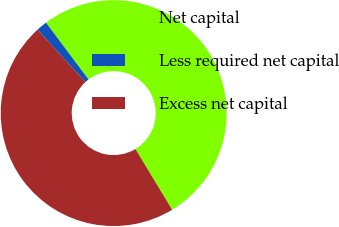Convert chart. <chart><loc_0><loc_0><loc_500><loc_500><pie_chart><fcel>Net capital<fcel>Less required net capital<fcel>Excess net capital<nl><fcel>51.57%<fcel>1.55%<fcel>46.88%<nl></chart> 